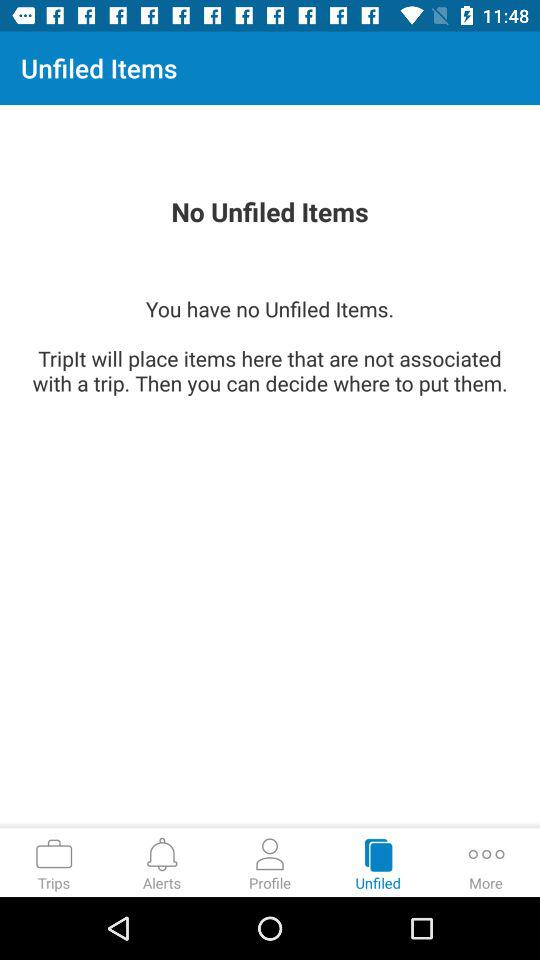What is the email address? The email address is appcrawler4@gmail.com. 